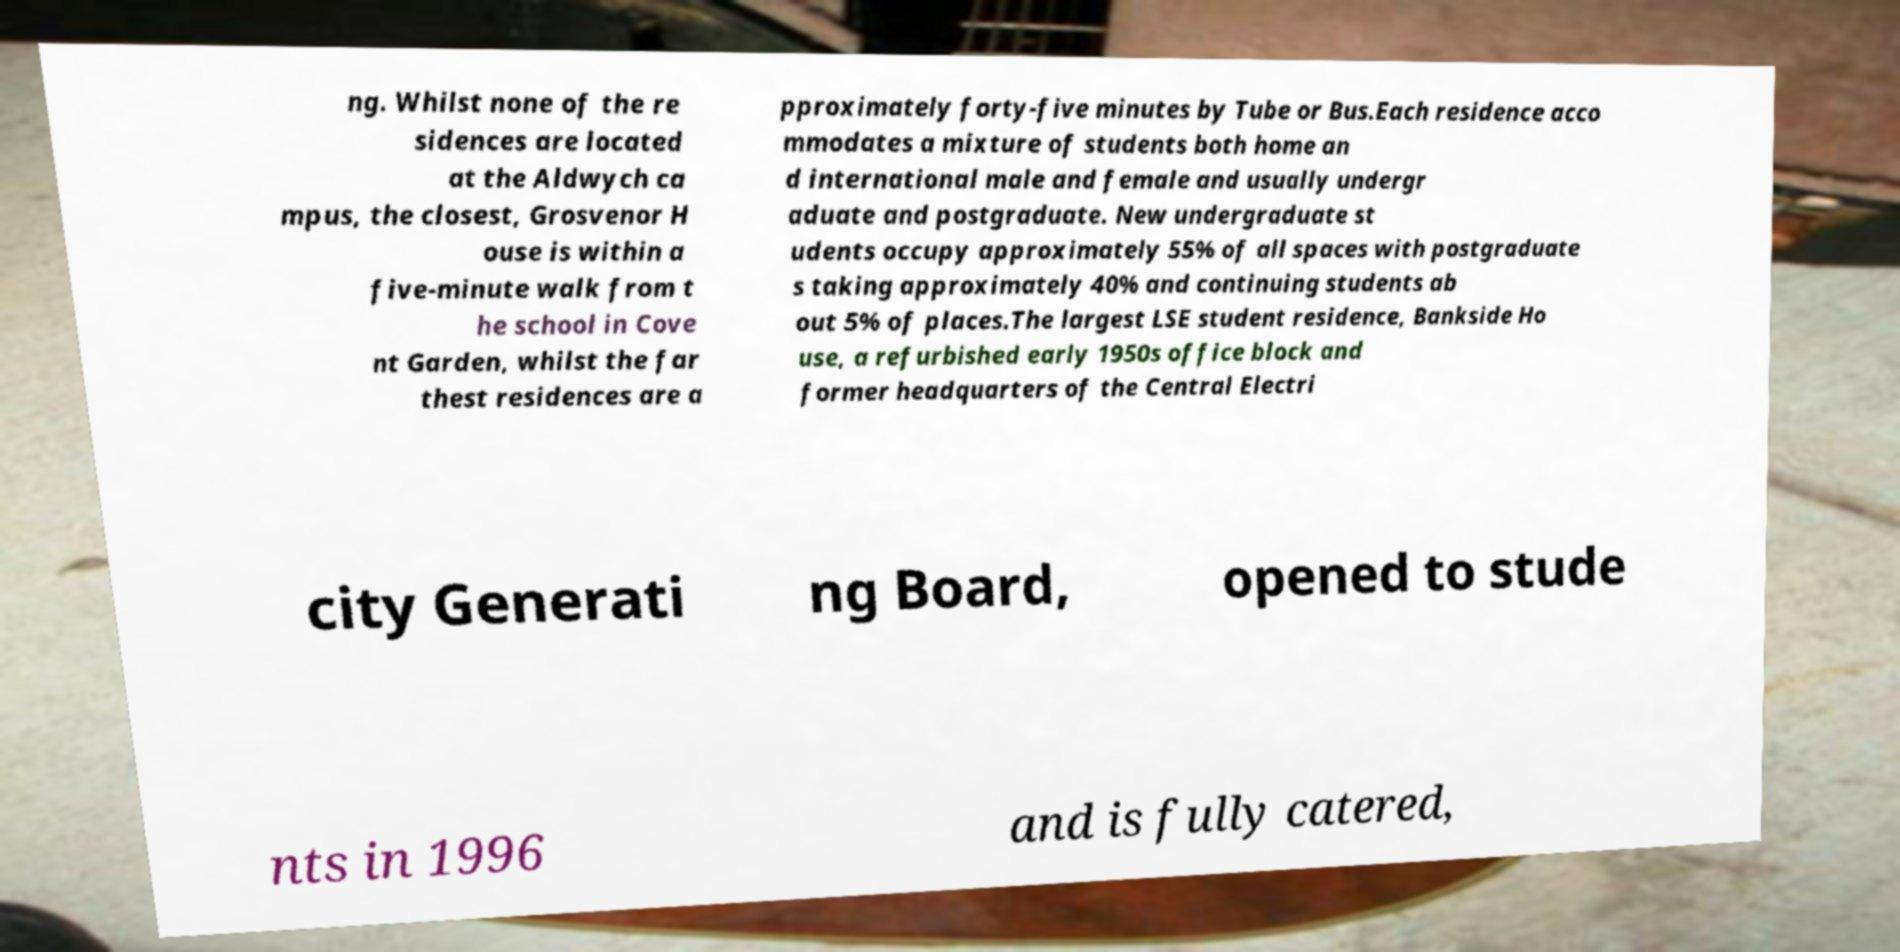Could you assist in decoding the text presented in this image and type it out clearly? ng. Whilst none of the re sidences are located at the Aldwych ca mpus, the closest, Grosvenor H ouse is within a five-minute walk from t he school in Cove nt Garden, whilst the far thest residences are a pproximately forty-five minutes by Tube or Bus.Each residence acco mmodates a mixture of students both home an d international male and female and usually undergr aduate and postgraduate. New undergraduate st udents occupy approximately 55% of all spaces with postgraduate s taking approximately 40% and continuing students ab out 5% of places.The largest LSE student residence, Bankside Ho use, a refurbished early 1950s office block and former headquarters of the Central Electri city Generati ng Board, opened to stude nts in 1996 and is fully catered, 